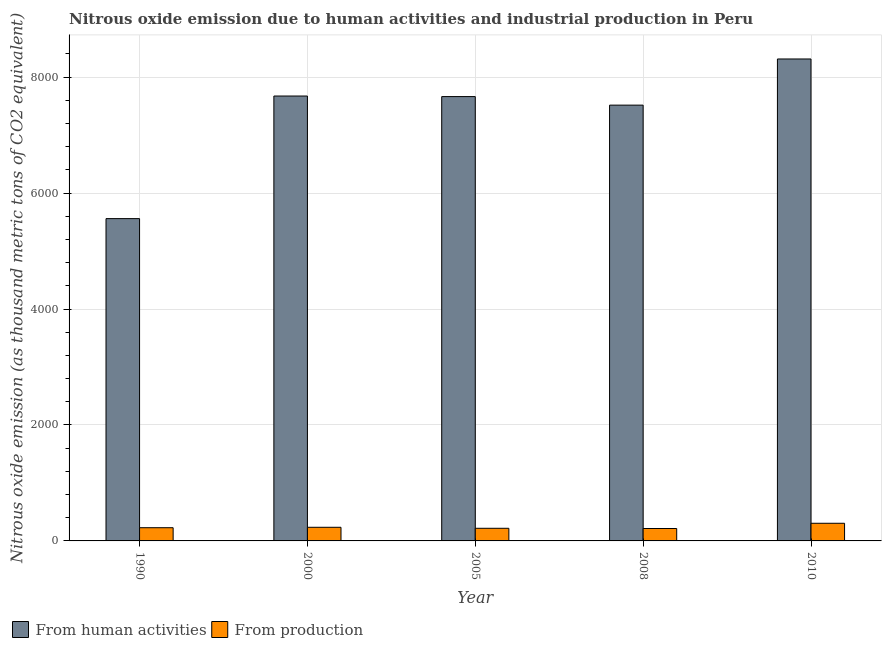How many groups of bars are there?
Your response must be concise. 5. Are the number of bars on each tick of the X-axis equal?
Ensure brevity in your answer.  Yes. How many bars are there on the 3rd tick from the left?
Give a very brief answer. 2. In how many cases, is the number of bars for a given year not equal to the number of legend labels?
Provide a succinct answer. 0. What is the amount of emissions generated from industries in 2010?
Make the answer very short. 304.4. Across all years, what is the maximum amount of emissions from human activities?
Offer a terse response. 8313. Across all years, what is the minimum amount of emissions from human activities?
Provide a succinct answer. 5559.3. In which year was the amount of emissions from human activities maximum?
Offer a very short reply. 2010. What is the total amount of emissions generated from industries in the graph?
Provide a succinct answer. 1199.4. What is the difference between the amount of emissions generated from industries in 2000 and that in 2005?
Offer a very short reply. 17.4. What is the difference between the amount of emissions from human activities in 1990 and the amount of emissions generated from industries in 2005?
Offer a very short reply. -2104.9. What is the average amount of emissions generated from industries per year?
Ensure brevity in your answer.  239.88. In how many years, is the amount of emissions generated from industries greater than 3200 thousand metric tons?
Provide a short and direct response. 0. What is the ratio of the amount of emissions generated from industries in 2005 to that in 2008?
Your response must be concise. 1.02. Is the difference between the amount of emissions from human activities in 2000 and 2008 greater than the difference between the amount of emissions generated from industries in 2000 and 2008?
Keep it short and to the point. No. What is the difference between the highest and the second highest amount of emissions generated from industries?
Your response must be concise. 69.2. What is the difference between the highest and the lowest amount of emissions generated from industries?
Make the answer very short. 90.3. Is the sum of the amount of emissions generated from industries in 2008 and 2010 greater than the maximum amount of emissions from human activities across all years?
Your response must be concise. Yes. What does the 2nd bar from the left in 1990 represents?
Ensure brevity in your answer.  From production. What does the 2nd bar from the right in 2005 represents?
Provide a short and direct response. From human activities. How many bars are there?
Provide a short and direct response. 10. Are the values on the major ticks of Y-axis written in scientific E-notation?
Offer a terse response. No. Does the graph contain any zero values?
Provide a succinct answer. No. Does the graph contain grids?
Your response must be concise. Yes. Where does the legend appear in the graph?
Make the answer very short. Bottom left. What is the title of the graph?
Give a very brief answer. Nitrous oxide emission due to human activities and industrial production in Peru. Does "Pregnant women" appear as one of the legend labels in the graph?
Make the answer very short. No. What is the label or title of the X-axis?
Give a very brief answer. Year. What is the label or title of the Y-axis?
Make the answer very short. Nitrous oxide emission (as thousand metric tons of CO2 equivalent). What is the Nitrous oxide emission (as thousand metric tons of CO2 equivalent) of From human activities in 1990?
Your answer should be very brief. 5559.3. What is the Nitrous oxide emission (as thousand metric tons of CO2 equivalent) of From production in 1990?
Your answer should be compact. 227.9. What is the Nitrous oxide emission (as thousand metric tons of CO2 equivalent) in From human activities in 2000?
Your answer should be compact. 7673.9. What is the Nitrous oxide emission (as thousand metric tons of CO2 equivalent) of From production in 2000?
Offer a terse response. 235.2. What is the Nitrous oxide emission (as thousand metric tons of CO2 equivalent) in From human activities in 2005?
Provide a succinct answer. 7664.2. What is the Nitrous oxide emission (as thousand metric tons of CO2 equivalent) in From production in 2005?
Your response must be concise. 217.8. What is the Nitrous oxide emission (as thousand metric tons of CO2 equivalent) in From human activities in 2008?
Offer a very short reply. 7516.8. What is the Nitrous oxide emission (as thousand metric tons of CO2 equivalent) in From production in 2008?
Provide a succinct answer. 214.1. What is the Nitrous oxide emission (as thousand metric tons of CO2 equivalent) in From human activities in 2010?
Provide a short and direct response. 8313. What is the Nitrous oxide emission (as thousand metric tons of CO2 equivalent) of From production in 2010?
Offer a terse response. 304.4. Across all years, what is the maximum Nitrous oxide emission (as thousand metric tons of CO2 equivalent) of From human activities?
Provide a succinct answer. 8313. Across all years, what is the maximum Nitrous oxide emission (as thousand metric tons of CO2 equivalent) in From production?
Your answer should be compact. 304.4. Across all years, what is the minimum Nitrous oxide emission (as thousand metric tons of CO2 equivalent) of From human activities?
Offer a very short reply. 5559.3. Across all years, what is the minimum Nitrous oxide emission (as thousand metric tons of CO2 equivalent) in From production?
Keep it short and to the point. 214.1. What is the total Nitrous oxide emission (as thousand metric tons of CO2 equivalent) of From human activities in the graph?
Your response must be concise. 3.67e+04. What is the total Nitrous oxide emission (as thousand metric tons of CO2 equivalent) of From production in the graph?
Make the answer very short. 1199.4. What is the difference between the Nitrous oxide emission (as thousand metric tons of CO2 equivalent) in From human activities in 1990 and that in 2000?
Ensure brevity in your answer.  -2114.6. What is the difference between the Nitrous oxide emission (as thousand metric tons of CO2 equivalent) of From human activities in 1990 and that in 2005?
Make the answer very short. -2104.9. What is the difference between the Nitrous oxide emission (as thousand metric tons of CO2 equivalent) in From production in 1990 and that in 2005?
Your response must be concise. 10.1. What is the difference between the Nitrous oxide emission (as thousand metric tons of CO2 equivalent) of From human activities in 1990 and that in 2008?
Offer a very short reply. -1957.5. What is the difference between the Nitrous oxide emission (as thousand metric tons of CO2 equivalent) of From human activities in 1990 and that in 2010?
Your answer should be compact. -2753.7. What is the difference between the Nitrous oxide emission (as thousand metric tons of CO2 equivalent) of From production in 1990 and that in 2010?
Make the answer very short. -76.5. What is the difference between the Nitrous oxide emission (as thousand metric tons of CO2 equivalent) in From human activities in 2000 and that in 2008?
Your response must be concise. 157.1. What is the difference between the Nitrous oxide emission (as thousand metric tons of CO2 equivalent) in From production in 2000 and that in 2008?
Give a very brief answer. 21.1. What is the difference between the Nitrous oxide emission (as thousand metric tons of CO2 equivalent) of From human activities in 2000 and that in 2010?
Provide a succinct answer. -639.1. What is the difference between the Nitrous oxide emission (as thousand metric tons of CO2 equivalent) in From production in 2000 and that in 2010?
Provide a succinct answer. -69.2. What is the difference between the Nitrous oxide emission (as thousand metric tons of CO2 equivalent) of From human activities in 2005 and that in 2008?
Your answer should be very brief. 147.4. What is the difference between the Nitrous oxide emission (as thousand metric tons of CO2 equivalent) of From human activities in 2005 and that in 2010?
Provide a succinct answer. -648.8. What is the difference between the Nitrous oxide emission (as thousand metric tons of CO2 equivalent) of From production in 2005 and that in 2010?
Make the answer very short. -86.6. What is the difference between the Nitrous oxide emission (as thousand metric tons of CO2 equivalent) in From human activities in 2008 and that in 2010?
Your response must be concise. -796.2. What is the difference between the Nitrous oxide emission (as thousand metric tons of CO2 equivalent) in From production in 2008 and that in 2010?
Ensure brevity in your answer.  -90.3. What is the difference between the Nitrous oxide emission (as thousand metric tons of CO2 equivalent) in From human activities in 1990 and the Nitrous oxide emission (as thousand metric tons of CO2 equivalent) in From production in 2000?
Your response must be concise. 5324.1. What is the difference between the Nitrous oxide emission (as thousand metric tons of CO2 equivalent) of From human activities in 1990 and the Nitrous oxide emission (as thousand metric tons of CO2 equivalent) of From production in 2005?
Your answer should be compact. 5341.5. What is the difference between the Nitrous oxide emission (as thousand metric tons of CO2 equivalent) of From human activities in 1990 and the Nitrous oxide emission (as thousand metric tons of CO2 equivalent) of From production in 2008?
Keep it short and to the point. 5345.2. What is the difference between the Nitrous oxide emission (as thousand metric tons of CO2 equivalent) of From human activities in 1990 and the Nitrous oxide emission (as thousand metric tons of CO2 equivalent) of From production in 2010?
Provide a short and direct response. 5254.9. What is the difference between the Nitrous oxide emission (as thousand metric tons of CO2 equivalent) of From human activities in 2000 and the Nitrous oxide emission (as thousand metric tons of CO2 equivalent) of From production in 2005?
Give a very brief answer. 7456.1. What is the difference between the Nitrous oxide emission (as thousand metric tons of CO2 equivalent) in From human activities in 2000 and the Nitrous oxide emission (as thousand metric tons of CO2 equivalent) in From production in 2008?
Ensure brevity in your answer.  7459.8. What is the difference between the Nitrous oxide emission (as thousand metric tons of CO2 equivalent) of From human activities in 2000 and the Nitrous oxide emission (as thousand metric tons of CO2 equivalent) of From production in 2010?
Your response must be concise. 7369.5. What is the difference between the Nitrous oxide emission (as thousand metric tons of CO2 equivalent) in From human activities in 2005 and the Nitrous oxide emission (as thousand metric tons of CO2 equivalent) in From production in 2008?
Your answer should be very brief. 7450.1. What is the difference between the Nitrous oxide emission (as thousand metric tons of CO2 equivalent) in From human activities in 2005 and the Nitrous oxide emission (as thousand metric tons of CO2 equivalent) in From production in 2010?
Your answer should be very brief. 7359.8. What is the difference between the Nitrous oxide emission (as thousand metric tons of CO2 equivalent) of From human activities in 2008 and the Nitrous oxide emission (as thousand metric tons of CO2 equivalent) of From production in 2010?
Offer a terse response. 7212.4. What is the average Nitrous oxide emission (as thousand metric tons of CO2 equivalent) in From human activities per year?
Provide a succinct answer. 7345.44. What is the average Nitrous oxide emission (as thousand metric tons of CO2 equivalent) of From production per year?
Provide a short and direct response. 239.88. In the year 1990, what is the difference between the Nitrous oxide emission (as thousand metric tons of CO2 equivalent) in From human activities and Nitrous oxide emission (as thousand metric tons of CO2 equivalent) in From production?
Keep it short and to the point. 5331.4. In the year 2000, what is the difference between the Nitrous oxide emission (as thousand metric tons of CO2 equivalent) of From human activities and Nitrous oxide emission (as thousand metric tons of CO2 equivalent) of From production?
Your answer should be very brief. 7438.7. In the year 2005, what is the difference between the Nitrous oxide emission (as thousand metric tons of CO2 equivalent) of From human activities and Nitrous oxide emission (as thousand metric tons of CO2 equivalent) of From production?
Provide a short and direct response. 7446.4. In the year 2008, what is the difference between the Nitrous oxide emission (as thousand metric tons of CO2 equivalent) in From human activities and Nitrous oxide emission (as thousand metric tons of CO2 equivalent) in From production?
Provide a short and direct response. 7302.7. In the year 2010, what is the difference between the Nitrous oxide emission (as thousand metric tons of CO2 equivalent) in From human activities and Nitrous oxide emission (as thousand metric tons of CO2 equivalent) in From production?
Give a very brief answer. 8008.6. What is the ratio of the Nitrous oxide emission (as thousand metric tons of CO2 equivalent) in From human activities in 1990 to that in 2000?
Provide a succinct answer. 0.72. What is the ratio of the Nitrous oxide emission (as thousand metric tons of CO2 equivalent) of From production in 1990 to that in 2000?
Your response must be concise. 0.97. What is the ratio of the Nitrous oxide emission (as thousand metric tons of CO2 equivalent) in From human activities in 1990 to that in 2005?
Ensure brevity in your answer.  0.73. What is the ratio of the Nitrous oxide emission (as thousand metric tons of CO2 equivalent) in From production in 1990 to that in 2005?
Keep it short and to the point. 1.05. What is the ratio of the Nitrous oxide emission (as thousand metric tons of CO2 equivalent) of From human activities in 1990 to that in 2008?
Provide a short and direct response. 0.74. What is the ratio of the Nitrous oxide emission (as thousand metric tons of CO2 equivalent) in From production in 1990 to that in 2008?
Offer a very short reply. 1.06. What is the ratio of the Nitrous oxide emission (as thousand metric tons of CO2 equivalent) in From human activities in 1990 to that in 2010?
Give a very brief answer. 0.67. What is the ratio of the Nitrous oxide emission (as thousand metric tons of CO2 equivalent) in From production in 1990 to that in 2010?
Offer a terse response. 0.75. What is the ratio of the Nitrous oxide emission (as thousand metric tons of CO2 equivalent) in From human activities in 2000 to that in 2005?
Your answer should be compact. 1. What is the ratio of the Nitrous oxide emission (as thousand metric tons of CO2 equivalent) in From production in 2000 to that in 2005?
Provide a short and direct response. 1.08. What is the ratio of the Nitrous oxide emission (as thousand metric tons of CO2 equivalent) of From human activities in 2000 to that in 2008?
Provide a short and direct response. 1.02. What is the ratio of the Nitrous oxide emission (as thousand metric tons of CO2 equivalent) in From production in 2000 to that in 2008?
Ensure brevity in your answer.  1.1. What is the ratio of the Nitrous oxide emission (as thousand metric tons of CO2 equivalent) in From human activities in 2000 to that in 2010?
Your answer should be compact. 0.92. What is the ratio of the Nitrous oxide emission (as thousand metric tons of CO2 equivalent) in From production in 2000 to that in 2010?
Provide a short and direct response. 0.77. What is the ratio of the Nitrous oxide emission (as thousand metric tons of CO2 equivalent) of From human activities in 2005 to that in 2008?
Keep it short and to the point. 1.02. What is the ratio of the Nitrous oxide emission (as thousand metric tons of CO2 equivalent) in From production in 2005 to that in 2008?
Your response must be concise. 1.02. What is the ratio of the Nitrous oxide emission (as thousand metric tons of CO2 equivalent) of From human activities in 2005 to that in 2010?
Your answer should be compact. 0.92. What is the ratio of the Nitrous oxide emission (as thousand metric tons of CO2 equivalent) in From production in 2005 to that in 2010?
Provide a succinct answer. 0.72. What is the ratio of the Nitrous oxide emission (as thousand metric tons of CO2 equivalent) in From human activities in 2008 to that in 2010?
Ensure brevity in your answer.  0.9. What is the ratio of the Nitrous oxide emission (as thousand metric tons of CO2 equivalent) of From production in 2008 to that in 2010?
Give a very brief answer. 0.7. What is the difference between the highest and the second highest Nitrous oxide emission (as thousand metric tons of CO2 equivalent) of From human activities?
Give a very brief answer. 639.1. What is the difference between the highest and the second highest Nitrous oxide emission (as thousand metric tons of CO2 equivalent) of From production?
Ensure brevity in your answer.  69.2. What is the difference between the highest and the lowest Nitrous oxide emission (as thousand metric tons of CO2 equivalent) of From human activities?
Your response must be concise. 2753.7. What is the difference between the highest and the lowest Nitrous oxide emission (as thousand metric tons of CO2 equivalent) of From production?
Your response must be concise. 90.3. 